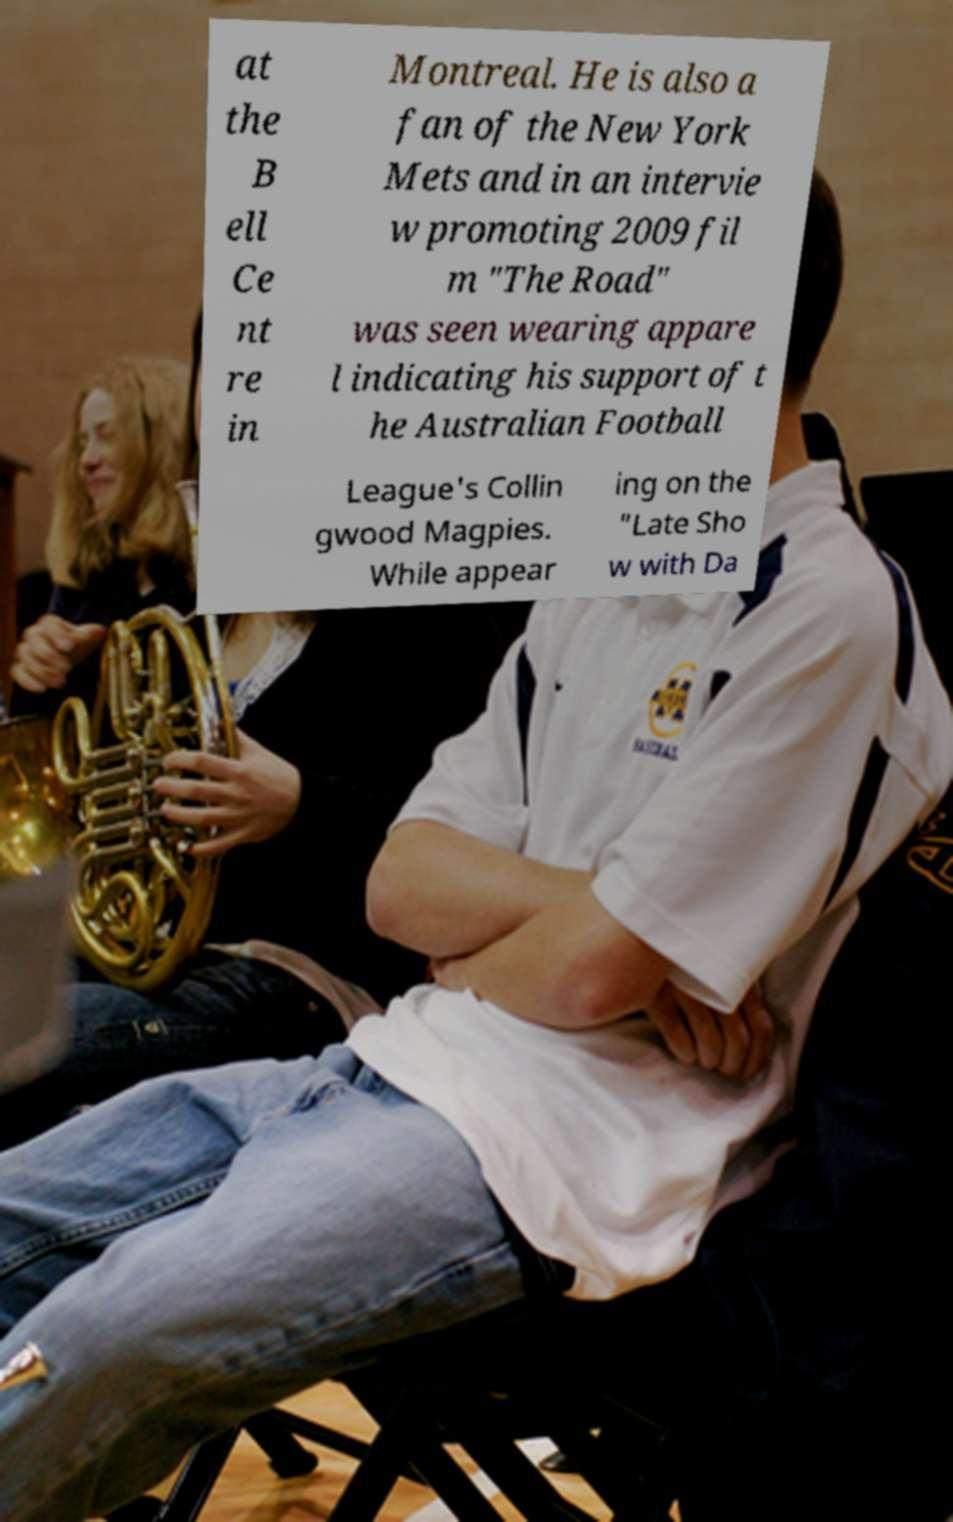I need the written content from this picture converted into text. Can you do that? at the B ell Ce nt re in Montreal. He is also a fan of the New York Mets and in an intervie w promoting 2009 fil m "The Road" was seen wearing appare l indicating his support of t he Australian Football League's Collin gwood Magpies. While appear ing on the "Late Sho w with Da 